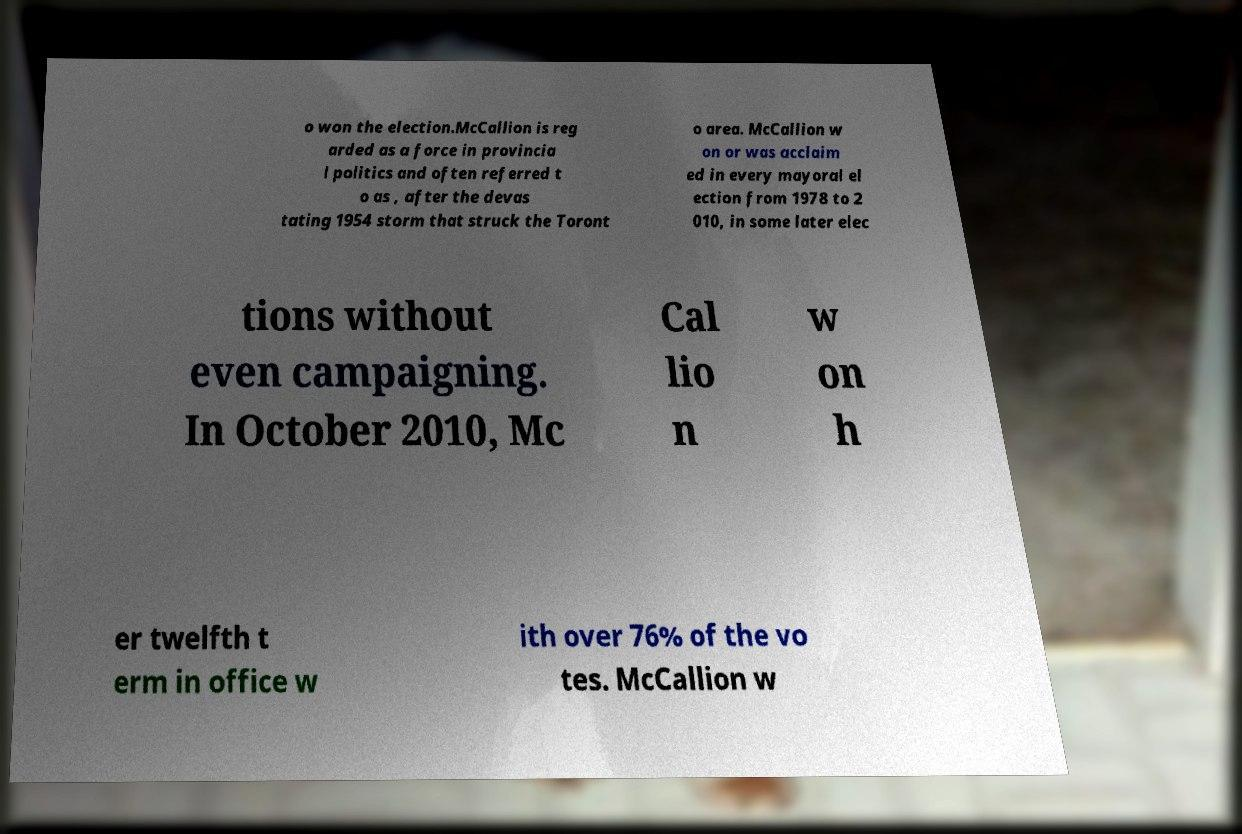Please read and relay the text visible in this image. What does it say? o won the election.McCallion is reg arded as a force in provincia l politics and often referred t o as , after the devas tating 1954 storm that struck the Toront o area. McCallion w on or was acclaim ed in every mayoral el ection from 1978 to 2 010, in some later elec tions without even campaigning. In October 2010, Mc Cal lio n w on h er twelfth t erm in office w ith over 76% of the vo tes. McCallion w 